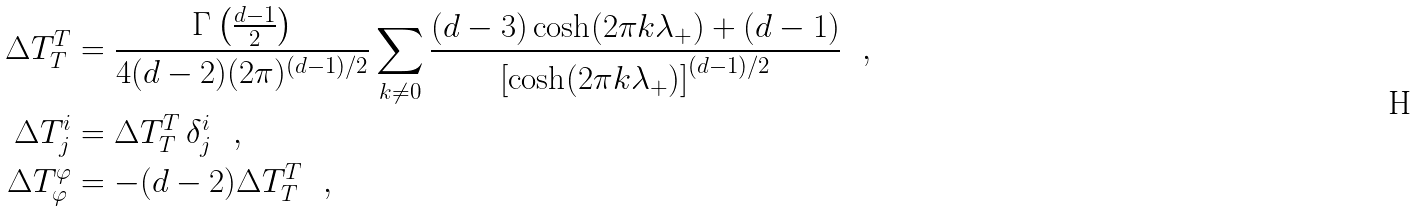<formula> <loc_0><loc_0><loc_500><loc_500>\Delta T ^ { T } _ { T } & = \frac { \Gamma \left ( \frac { d - 1 } { 2 } \right ) } { 4 ( d - 2 ) ( 2 \pi ) ^ { ( d - 1 ) / 2 } } \sum _ { k \neq 0 } \frac { ( d - 3 ) \cosh ( 2 \pi k \lambda _ { + } ) + ( d - 1 ) } { { \left [ \cosh ( 2 \pi k \lambda _ { + } ) \right ] } ^ { ( d - 1 ) / 2 } } \ \ , \\ \Delta T ^ { i } _ { j } & = \Delta T ^ { T } _ { T } \, \delta ^ { i } _ { j } \ \ , \\ \Delta T ^ { \varphi } _ { \varphi } & = - ( d - 2 ) \Delta T ^ { T } _ { T } \ \ ,</formula> 